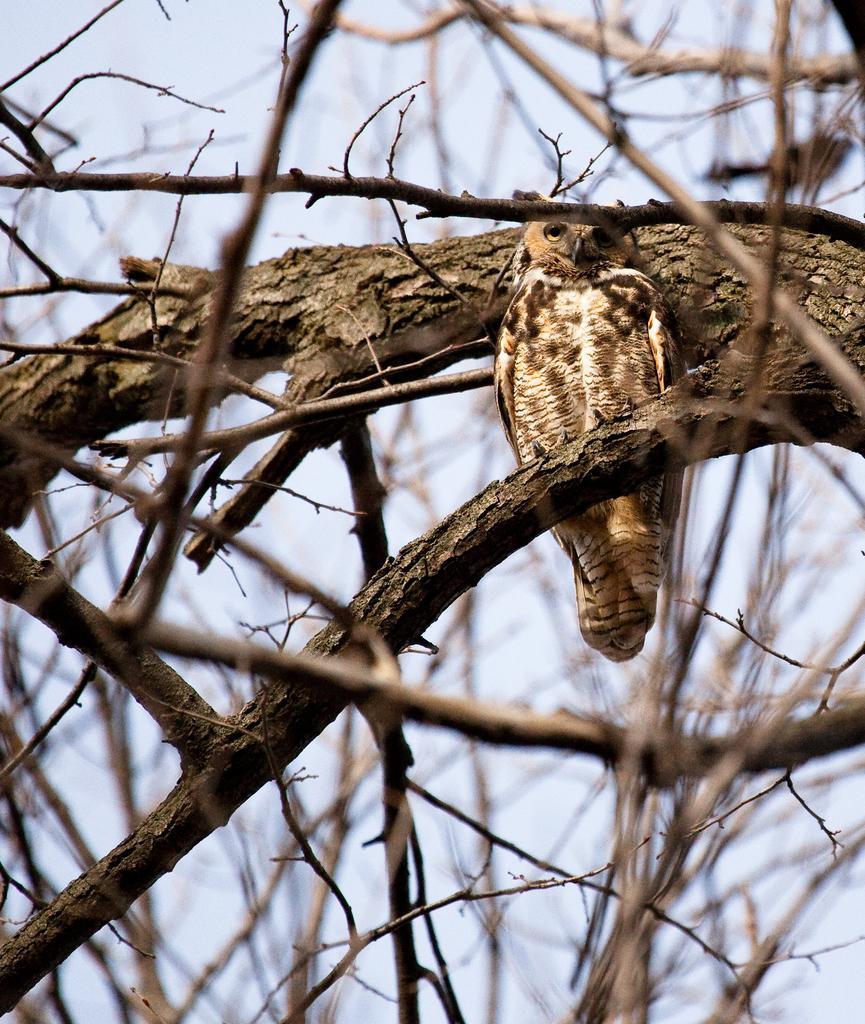Describe this image in one or two sentences. In the image we can see an owl sitting on the tree branch. These are the three branches and a pale blue sky. 